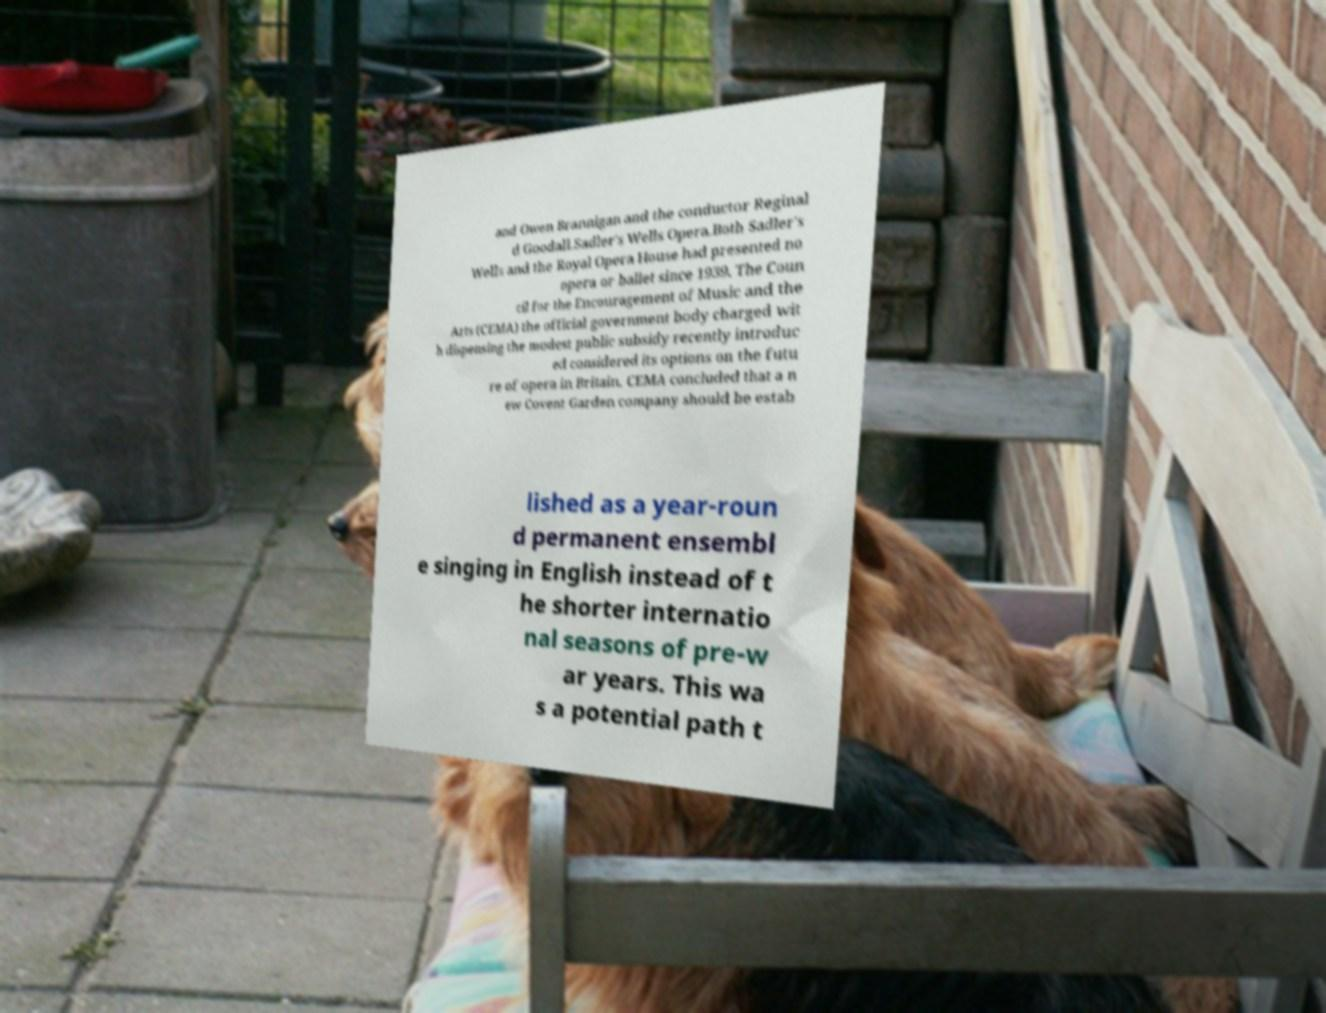Please read and relay the text visible in this image. What does it say? and Owen Brannigan and the conductor Reginal d Goodall.Sadler's Wells Opera.Both Sadler's Wells and the Royal Opera House had presented no opera or ballet since 1939. The Coun cil for the Encouragement of Music and the Arts (CEMA) the official government body charged wit h dispensing the modest public subsidy recently introduc ed considered its options on the futu re of opera in Britain. CEMA concluded that a n ew Covent Garden company should be estab lished as a year-roun d permanent ensembl e singing in English instead of t he shorter internatio nal seasons of pre-w ar years. This wa s a potential path t 